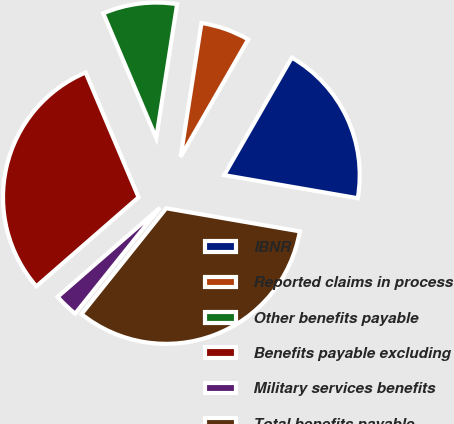Convert chart. <chart><loc_0><loc_0><loc_500><loc_500><pie_chart><fcel>IBNR<fcel>Reported claims in process<fcel>Other benefits payable<fcel>Benefits payable excluding<fcel>Military services benefits<fcel>Total benefits payable<nl><fcel>19.41%<fcel>5.85%<fcel>8.85%<fcel>30.02%<fcel>2.85%<fcel>33.02%<nl></chart> 